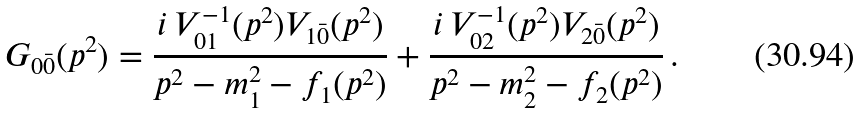Convert formula to latex. <formula><loc_0><loc_0><loc_500><loc_500>G _ { 0 \bar { 0 } } ( p ^ { 2 } ) = \frac { i \, V _ { 0 1 } ^ { - 1 } ( p ^ { 2 } ) V _ { 1 \bar { 0 } } ( p ^ { 2 } ) } { p ^ { 2 } - m _ { 1 } ^ { 2 } - f _ { 1 } ( p ^ { 2 } ) } + \frac { i \, V _ { 0 2 } ^ { - 1 } ( p ^ { 2 } ) V _ { 2 \bar { 0 } } ( p ^ { 2 } ) } { p ^ { 2 } - m _ { 2 } ^ { 2 } - f _ { 2 } ( p ^ { 2 } ) } \, .</formula> 